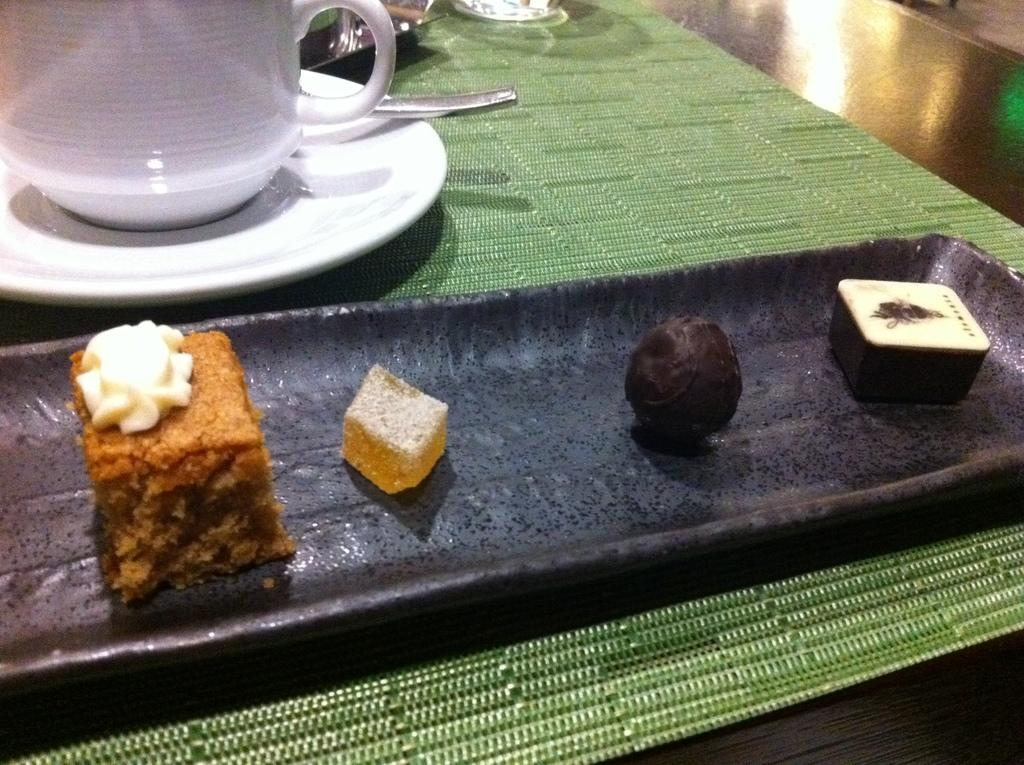What is covering the table in the image? There is a green carpet on the table. What else can be seen on the table? There is a plate, a cup, and food in a tray on the table. Is there a rat hiding under the green carpet on the table? There is no rat present in the image; it only shows a green carpet, a plate, a cup, and food in a tray on the table. 